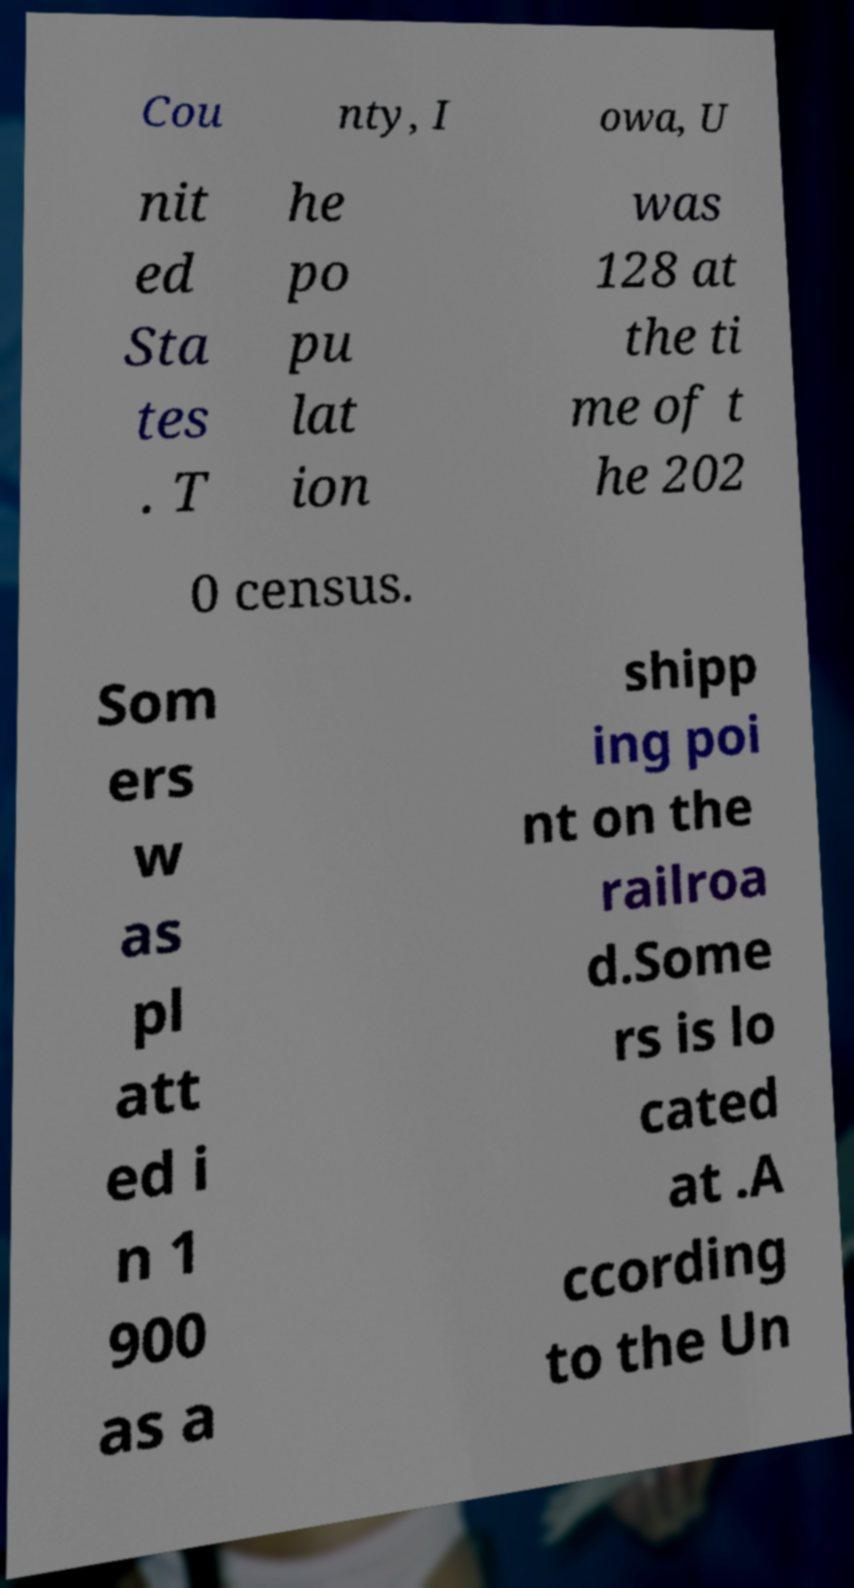Could you extract and type out the text from this image? Cou nty, I owa, U nit ed Sta tes . T he po pu lat ion was 128 at the ti me of t he 202 0 census. Som ers w as pl att ed i n 1 900 as a shipp ing poi nt on the railroa d.Some rs is lo cated at .A ccording to the Un 